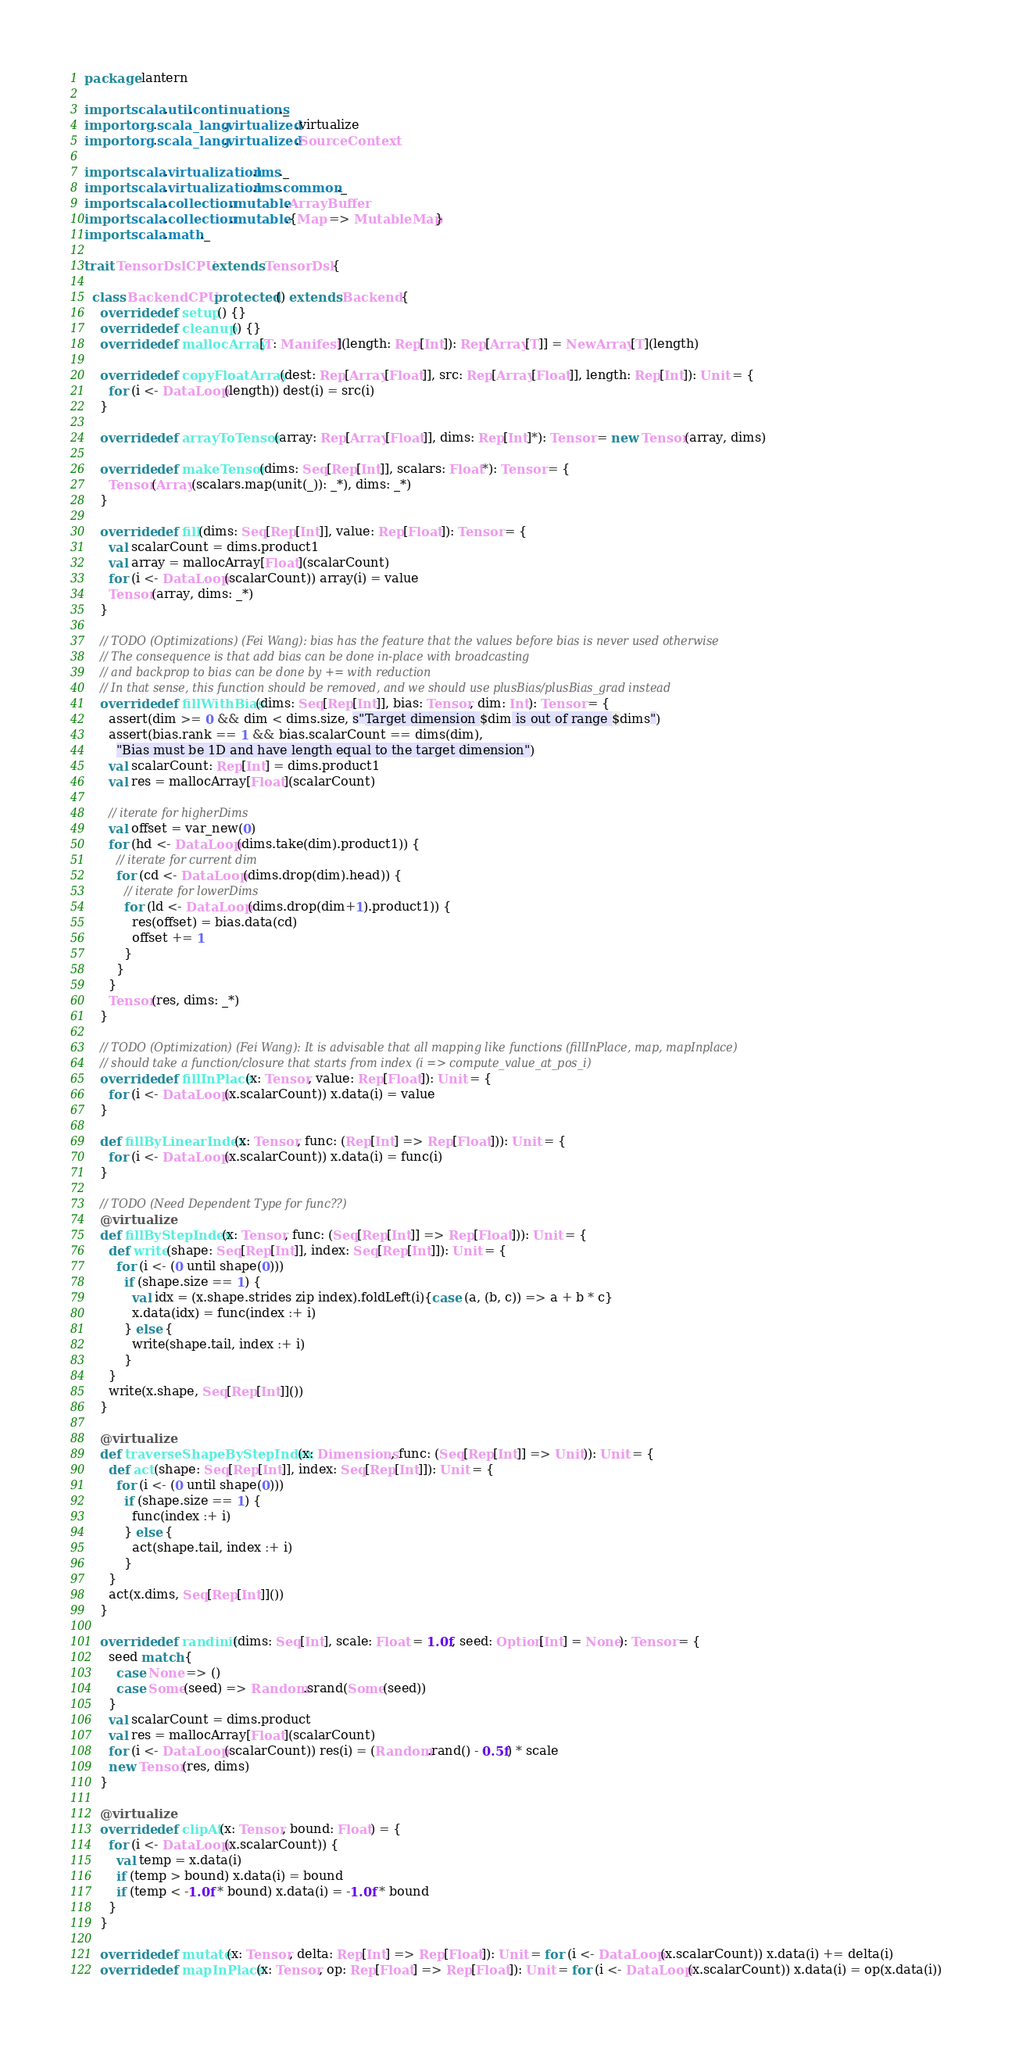Convert code to text. <code><loc_0><loc_0><loc_500><loc_500><_Scala_>package lantern

import scala.util.continuations._
import org.scala_lang.virtualized.virtualize
import org.scala_lang.virtualized.SourceContext

import scala.virtualization.lms._
import scala.virtualization.lms.common._
import scala.collection.mutable.ArrayBuffer
import scala.collection.mutable.{Map => MutableMap}
import scala.math._

trait TensorDslCPU extends TensorDsl {

  class BackendCPU protected() extends Backend {
    override def setup() {}
    override def cleanup() {}
    override def mallocArray[T: Manifest](length: Rep[Int]): Rep[Array[T]] = NewArray[T](length)

    override def copyFloatArray(dest: Rep[Array[Float]], src: Rep[Array[Float]], length: Rep[Int]): Unit = {
      for (i <- DataLoop(length)) dest(i) = src(i)
    }

    override def arrayToTensor(array: Rep[Array[Float]], dims: Rep[Int]*): Tensor = new Tensor(array, dims)

    override def makeTensor(dims: Seq[Rep[Int]], scalars: Float*): Tensor = {
      Tensor(Array(scalars.map(unit(_)): _*), dims: _*)
    }

    override def fill(dims: Seq[Rep[Int]], value: Rep[Float]): Tensor = {
      val scalarCount = dims.product1
      val array = mallocArray[Float](scalarCount)
      for (i <- DataLoop(scalarCount)) array(i) = value
      Tensor(array, dims: _*)
    }

    // TODO (Optimizations) (Fei Wang): bias has the feature that the values before bias is never used otherwise
    // The consequence is that add bias can be done in-place with broadcasting
    // and backprop to bias can be done by += with reduction
    // In that sense, this function should be removed, and we should use plusBias/plusBias_grad instead
    override def fillWithBias(dims: Seq[Rep[Int]], bias: Tensor, dim: Int): Tensor = {
      assert(dim >= 0 && dim < dims.size, s"Target dimension $dim is out of range $dims")
      assert(bias.rank == 1 && bias.scalarCount == dims(dim),
        "Bias must be 1D and have length equal to the target dimension")
      val scalarCount: Rep[Int] = dims.product1
      val res = mallocArray[Float](scalarCount)

      // iterate for higherDims
      val offset = var_new(0)
      for (hd <- DataLoop(dims.take(dim).product1)) {
        // iterate for current dim
        for (cd <- DataLoop(dims.drop(dim).head)) {
          // iterate for lowerDims
          for (ld <- DataLoop(dims.drop(dim+1).product1)) {
            res(offset) = bias.data(cd)
            offset += 1
          }
        }
      }
      Tensor(res, dims: _*)
    }

    // TODO (Optimization) (Fei Wang): It is advisable that all mapping like functions (fillInPlace, map, mapInplace)
    // should take a function/closure that starts from index (i => compute_value_at_pos_i)
    override def fillInPlace(x: Tensor, value: Rep[Float]): Unit = {
      for (i <- DataLoop(x.scalarCount)) x.data(i) = value
    }

    def fillByLinearIndex(x: Tensor, func: (Rep[Int] => Rep[Float])): Unit = {
      for (i <- DataLoop(x.scalarCount)) x.data(i) = func(i)
    }

    // TODO (Need Dependent Type for func??)
    @virtualize
    def fillByStepIndex(x: Tensor, func: (Seq[Rep[Int]] => Rep[Float])): Unit = {
      def write(shape: Seq[Rep[Int]], index: Seq[Rep[Int]]): Unit = {
        for (i <- (0 until shape(0)))
          if (shape.size == 1) {
            val idx = (x.shape.strides zip index).foldLeft(i){case (a, (b, c)) => a + b * c}
            x.data(idx) = func(index :+ i)
          } else {
            write(shape.tail, index :+ i)
          }
      }
      write(x.shape, Seq[Rep[Int]]())
    }

    @virtualize
    def traverseShapeByStepIndex(x: Dimensions, func: (Seq[Rep[Int]] => Unit)): Unit = {
      def act(shape: Seq[Rep[Int]], index: Seq[Rep[Int]]): Unit = {
        for (i <- (0 until shape(0)))
          if (shape.size == 1) {
            func(index :+ i)
          } else {
            act(shape.tail, index :+ i)
          }
      }
      act(x.dims, Seq[Rep[Int]]())
    }

    override def randinit(dims: Seq[Int], scale: Float = 1.0f, seed: Option[Int] = None): Tensor = {
      seed match {
        case None => ()
        case Some(seed) => Random.srand(Some(seed))
      }
      val scalarCount = dims.product
      val res = mallocArray[Float](scalarCount)
      for (i <- DataLoop(scalarCount)) res(i) = (Random.rand() - 0.5f) * scale
      new Tensor(res, dims)
    }

    @virtualize
    override def clipAt(x: Tensor, bound: Float) = {
      for (i <- DataLoop(x.scalarCount)) {
        val temp = x.data(i)
        if (temp > bound) x.data(i) = bound
        if (temp < -1.0f * bound) x.data(i) = -1.0f * bound
      }
    }

    override def mutate(x: Tensor, delta: Rep[Int] => Rep[Float]): Unit = for (i <- DataLoop(x.scalarCount)) x.data(i) += delta(i)
    override def mapInPlace(x: Tensor, op: Rep[Float] => Rep[Float]): Unit = for (i <- DataLoop(x.scalarCount)) x.data(i) = op(x.data(i))</code> 